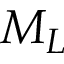Convert formula to latex. <formula><loc_0><loc_0><loc_500><loc_500>M _ { L }</formula> 